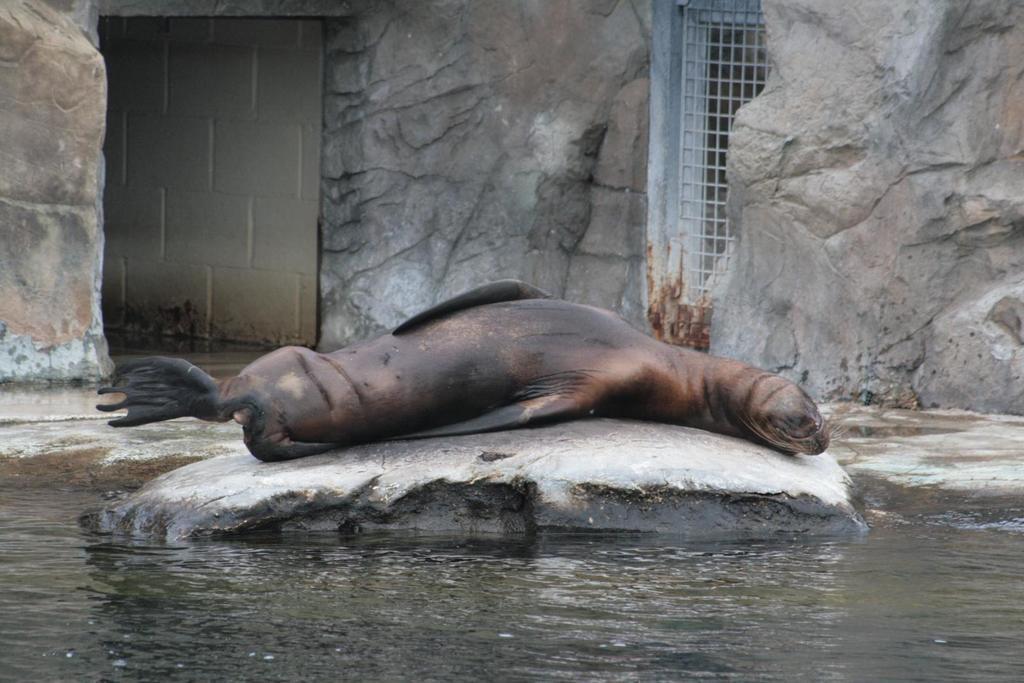Describe this image in one or two sentences. In this image we can see a spinner dolphin on the rock. We can also see the water, a metal grill, the rocks and a wall. 